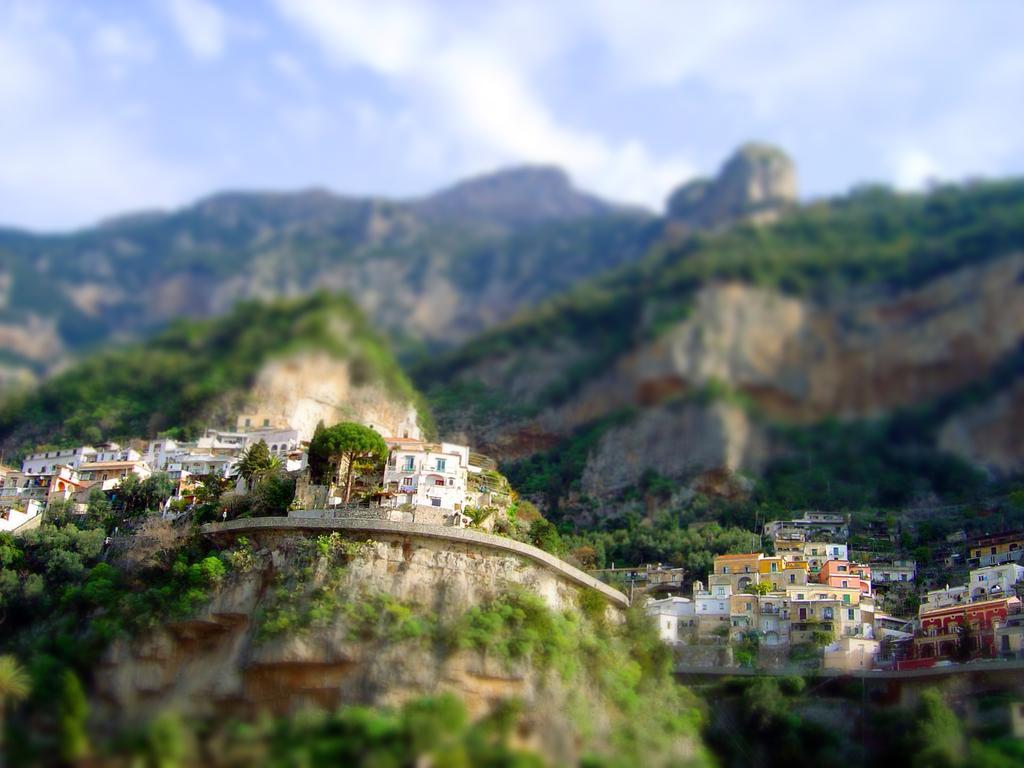Can you describe this image briefly? In this image, we can see so many buildings, trees. Background there is a blur view. Here we can see mountains. Top of the image, there is a sky. 